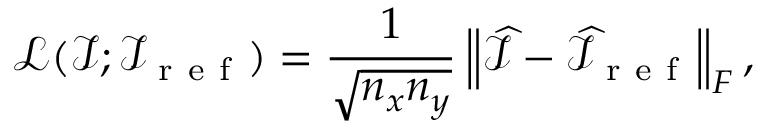Convert formula to latex. <formula><loc_0><loc_0><loc_500><loc_500>\mathcal { L } ( \mathcal { I } ; \mathcal { I } _ { r e f } ) = \frac { 1 } { \sqrt { n _ { x } n _ { y } } } \left \| \widehat { \mathcal { I } } - \widehat { \mathcal { I } } _ { r e f } \right \| _ { F } ,</formula> 